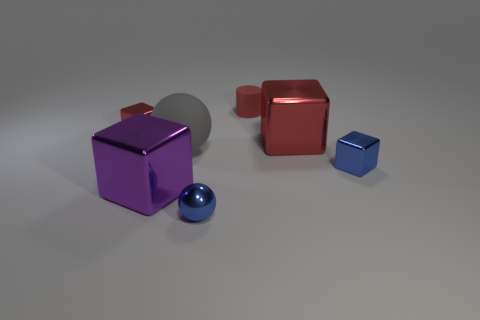How many other things are the same size as the purple cube?
Your response must be concise. 2. Do the blue metal thing that is to the left of the small rubber thing and the small thing that is behind the small red cube have the same shape?
Provide a short and direct response. No. Is the number of big purple metal things behind the large gray sphere less than the number of blue rubber objects?
Offer a very short reply. No. What number of big spheres are the same color as the small metallic sphere?
Provide a short and direct response. 0. What size is the red metal block to the left of the red cylinder?
Your answer should be compact. Small. What is the shape of the big metallic object that is left of the metal thing in front of the big block in front of the blue metallic cube?
Your response must be concise. Cube. The shiny thing that is both to the left of the blue metallic sphere and in front of the gray sphere has what shape?
Offer a very short reply. Cube. Are there any yellow metal things of the same size as the purple object?
Ensure brevity in your answer.  No. Do the blue object behind the metal ball and the gray thing have the same shape?
Your response must be concise. No. Do the small rubber object and the big gray object have the same shape?
Provide a succinct answer. No. 